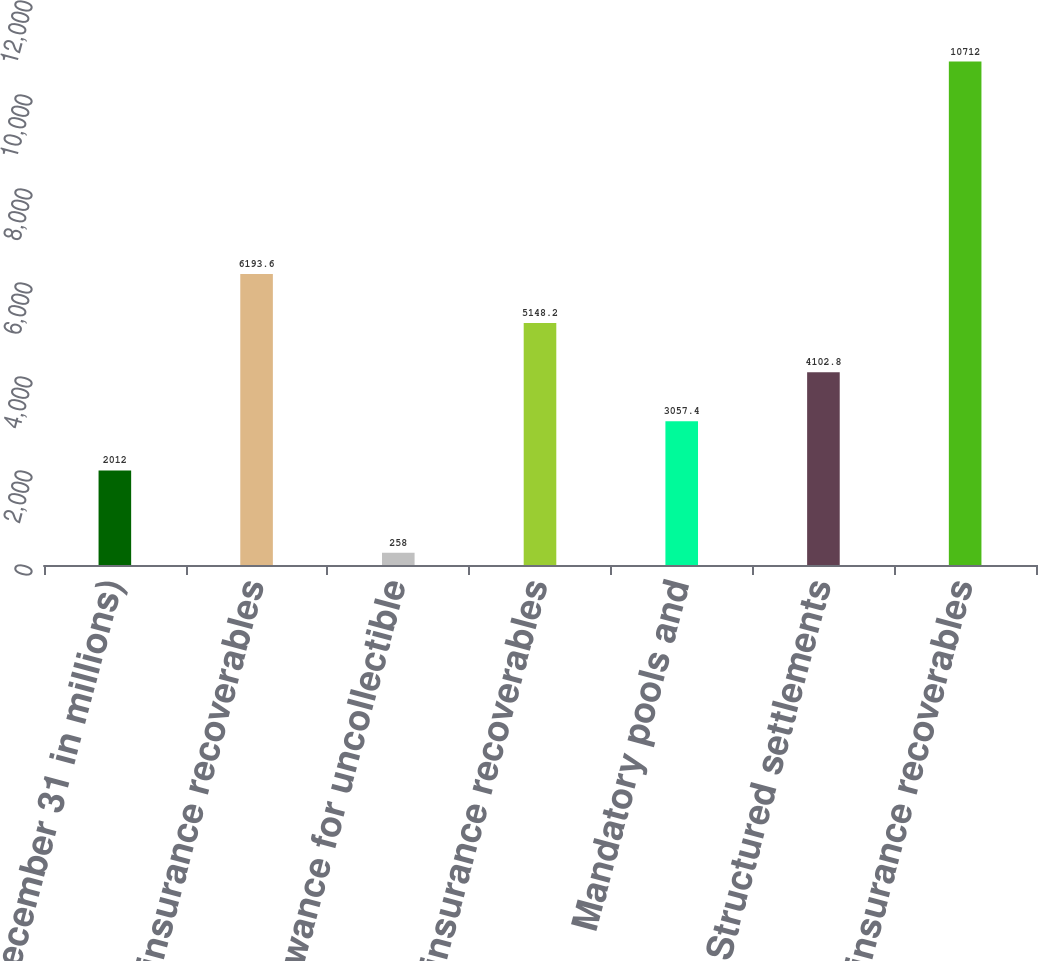Convert chart. <chart><loc_0><loc_0><loc_500><loc_500><bar_chart><fcel>(at December 31 in millions)<fcel>Gross reinsurance recoverables<fcel>Allowance for uncollectible<fcel>Net reinsurance recoverables<fcel>Mandatory pools and<fcel>Structured settlements<fcel>Total reinsurance recoverables<nl><fcel>2012<fcel>6193.6<fcel>258<fcel>5148.2<fcel>3057.4<fcel>4102.8<fcel>10712<nl></chart> 